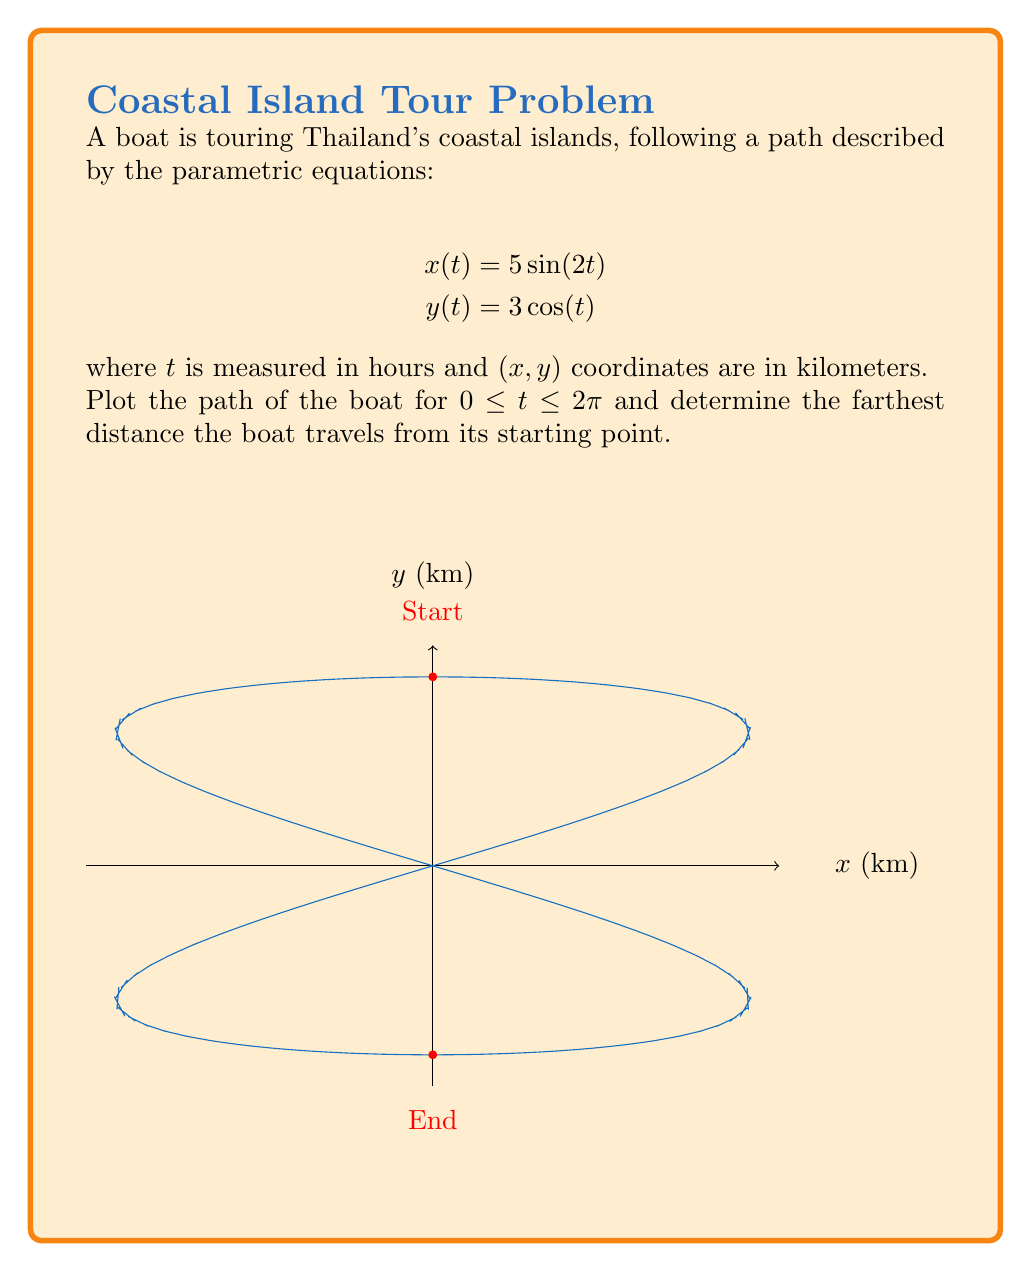Give your solution to this math problem. Let's approach this step-by-step:

1) First, we need to plot the path. The given parametric equations are:
   $$x(t) = 5\sin(2t)$$
   $$y(t) = 3\cos(t)$$

2) To find the farthest distance from the starting point, we need to:
   a) Determine the starting point
   b) Find the maximum distance from this point

3) The starting point is at $t=0$:
   $$x(0) = 5\sin(0) = 0$$
   $$y(0) = 3\cos(0) = 3$$
   So, the starting point is $(0,3)$.

4) The distance from the starting point at any time $t$ is given by:
   $$d(t) = \sqrt{(x(t)-0)^2 + (y(t)-3)^2}$$
   $$d(t) = \sqrt{(5\sin(2t))^2 + (3\cos(t)-3)^2}$$

5) To find the maximum distance, we need to find the maximum value of $d(t)$. This is a complex function, so let's consider the maximum possible values of its components:

   - The maximum value of $5\sin(2t)$ is 5
   - The maximum value of $3\cos(t)-3$ is 3 (when $\cos(t)=2$)

6) Therefore, the maximum possible distance is:
   $$d_{max} = \sqrt{5^2 + 3^2} = \sqrt{34} \approx 5.83 \text{ km}$$

This occurs when the boat is at $(0,-3)$, which is at $t=\pi$.
Answer: The farthest distance is $\sqrt{34}$ km (approximately 5.83 km). 